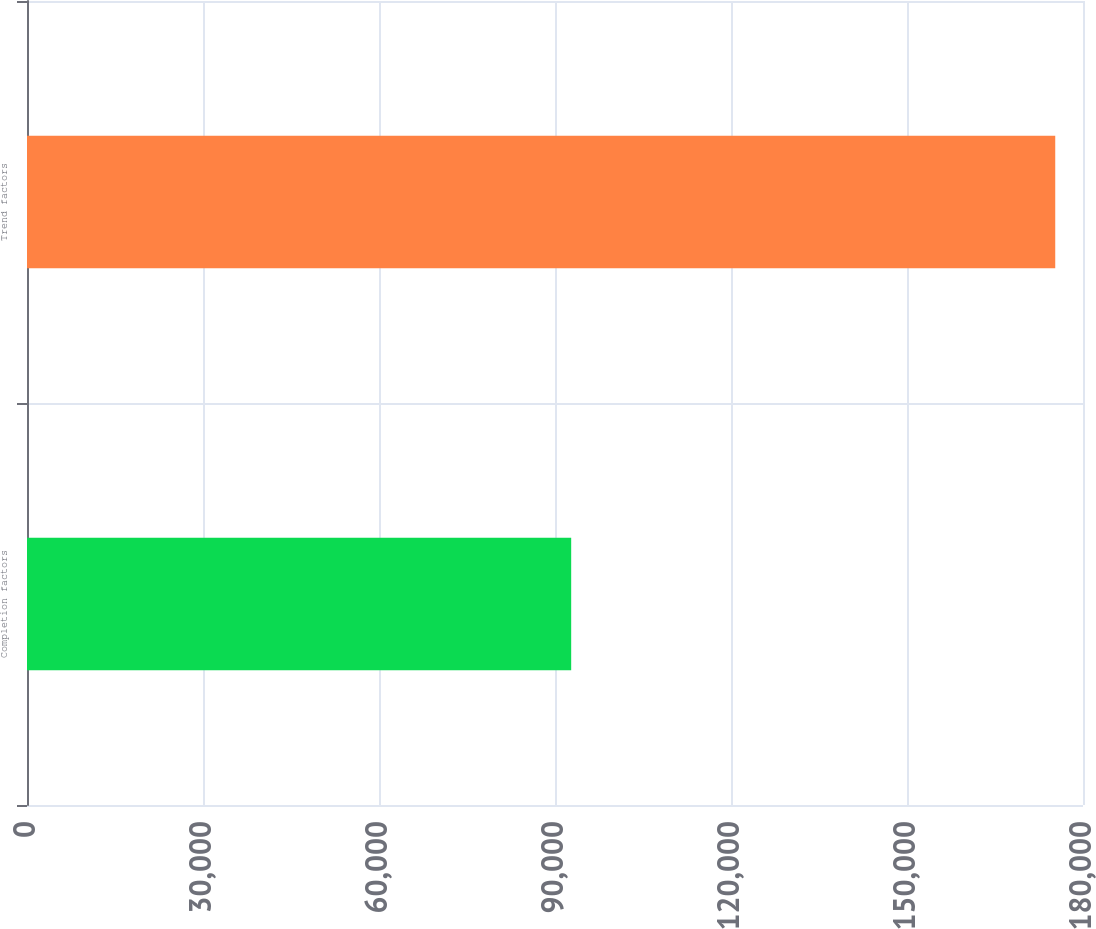<chart> <loc_0><loc_0><loc_500><loc_500><bar_chart><fcel>Completion factors<fcel>Trend factors<nl><fcel>92759<fcel>175268<nl></chart> 